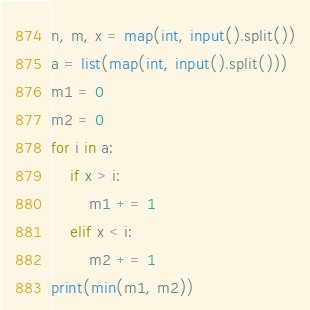Convert code to text. <code><loc_0><loc_0><loc_500><loc_500><_Python_>n, m, x = map(int, input().split())
a = list(map(int, input().split()))
m1 = 0
m2 = 0
for i in a:
    if x > i:
        m1 += 1
    elif x < i:
        m2 += 1
print(min(m1, m2))
</code> 